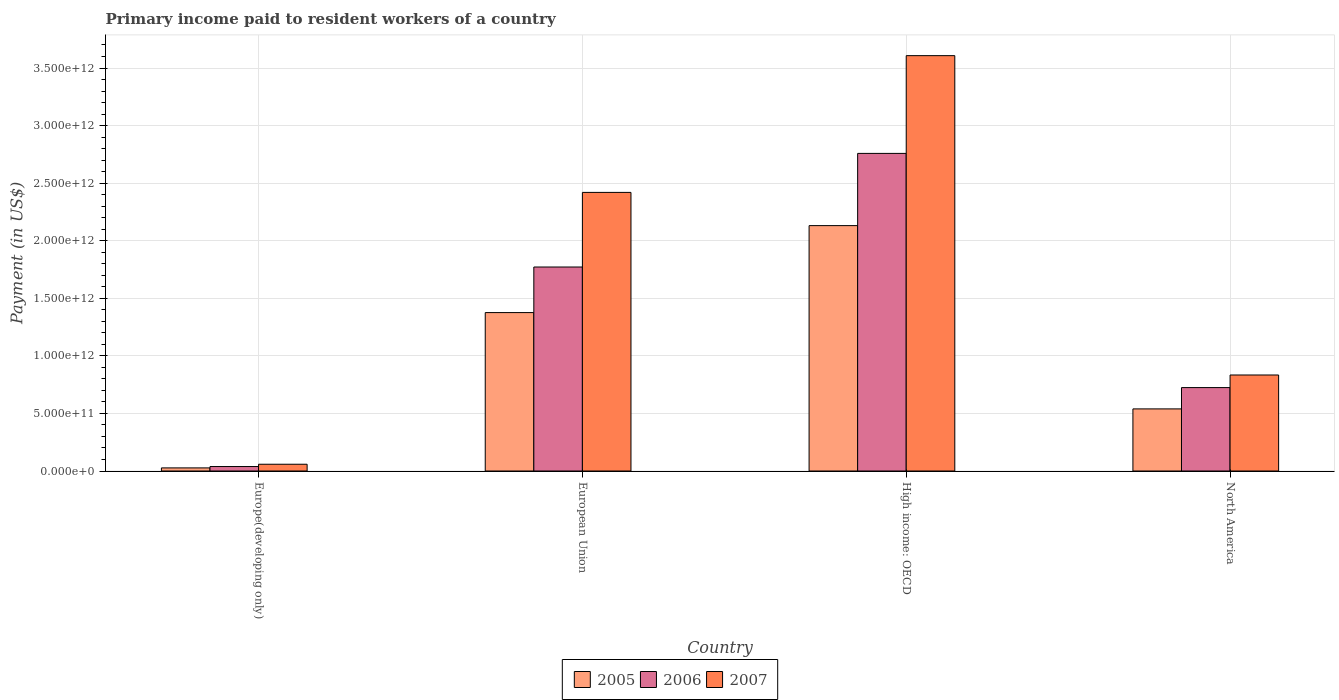How many groups of bars are there?
Provide a short and direct response. 4. Are the number of bars on each tick of the X-axis equal?
Ensure brevity in your answer.  Yes. What is the label of the 3rd group of bars from the left?
Offer a terse response. High income: OECD. What is the amount paid to workers in 2007 in North America?
Your answer should be very brief. 8.34e+11. Across all countries, what is the maximum amount paid to workers in 2007?
Give a very brief answer. 3.61e+12. Across all countries, what is the minimum amount paid to workers in 2006?
Your answer should be very brief. 3.88e+1. In which country was the amount paid to workers in 2007 maximum?
Offer a terse response. High income: OECD. In which country was the amount paid to workers in 2006 minimum?
Offer a terse response. Europe(developing only). What is the total amount paid to workers in 2005 in the graph?
Your answer should be very brief. 4.07e+12. What is the difference between the amount paid to workers in 2005 in Europe(developing only) and that in High income: OECD?
Provide a short and direct response. -2.10e+12. What is the difference between the amount paid to workers in 2005 in European Union and the amount paid to workers in 2006 in Europe(developing only)?
Your answer should be very brief. 1.34e+12. What is the average amount paid to workers in 2006 per country?
Ensure brevity in your answer.  1.32e+12. What is the difference between the amount paid to workers of/in 2007 and amount paid to workers of/in 2006 in Europe(developing only)?
Your response must be concise. 1.99e+1. In how many countries, is the amount paid to workers in 2007 greater than 2500000000000 US$?
Give a very brief answer. 1. What is the ratio of the amount paid to workers in 2006 in Europe(developing only) to that in European Union?
Ensure brevity in your answer.  0.02. Is the difference between the amount paid to workers in 2007 in High income: OECD and North America greater than the difference between the amount paid to workers in 2006 in High income: OECD and North America?
Offer a terse response. Yes. What is the difference between the highest and the second highest amount paid to workers in 2006?
Give a very brief answer. -9.87e+11. What is the difference between the highest and the lowest amount paid to workers in 2005?
Your answer should be very brief. 2.10e+12. In how many countries, is the amount paid to workers in 2007 greater than the average amount paid to workers in 2007 taken over all countries?
Offer a very short reply. 2. Is the sum of the amount paid to workers in 2005 in European Union and North America greater than the maximum amount paid to workers in 2006 across all countries?
Make the answer very short. No. What does the 3rd bar from the left in North America represents?
Ensure brevity in your answer.  2007. Is it the case that in every country, the sum of the amount paid to workers in 2005 and amount paid to workers in 2006 is greater than the amount paid to workers in 2007?
Your response must be concise. Yes. Are all the bars in the graph horizontal?
Provide a short and direct response. No. What is the difference between two consecutive major ticks on the Y-axis?
Provide a short and direct response. 5.00e+11. Are the values on the major ticks of Y-axis written in scientific E-notation?
Your response must be concise. Yes. Does the graph contain any zero values?
Provide a succinct answer. No. Does the graph contain grids?
Ensure brevity in your answer.  Yes. Where does the legend appear in the graph?
Offer a very short reply. Bottom center. How are the legend labels stacked?
Provide a succinct answer. Horizontal. What is the title of the graph?
Your answer should be very brief. Primary income paid to resident workers of a country. What is the label or title of the Y-axis?
Your answer should be compact. Payment (in US$). What is the Payment (in US$) in 2005 in Europe(developing only)?
Offer a very short reply. 2.70e+1. What is the Payment (in US$) of 2006 in Europe(developing only)?
Your answer should be compact. 3.88e+1. What is the Payment (in US$) of 2007 in Europe(developing only)?
Make the answer very short. 5.87e+1. What is the Payment (in US$) of 2005 in European Union?
Make the answer very short. 1.38e+12. What is the Payment (in US$) in 2006 in European Union?
Offer a terse response. 1.77e+12. What is the Payment (in US$) in 2007 in European Union?
Provide a succinct answer. 2.42e+12. What is the Payment (in US$) of 2005 in High income: OECD?
Keep it short and to the point. 2.13e+12. What is the Payment (in US$) in 2006 in High income: OECD?
Ensure brevity in your answer.  2.76e+12. What is the Payment (in US$) in 2007 in High income: OECD?
Your response must be concise. 3.61e+12. What is the Payment (in US$) of 2005 in North America?
Provide a succinct answer. 5.39e+11. What is the Payment (in US$) in 2006 in North America?
Ensure brevity in your answer.  7.24e+11. What is the Payment (in US$) of 2007 in North America?
Provide a succinct answer. 8.34e+11. Across all countries, what is the maximum Payment (in US$) in 2005?
Keep it short and to the point. 2.13e+12. Across all countries, what is the maximum Payment (in US$) in 2006?
Offer a terse response. 2.76e+12. Across all countries, what is the maximum Payment (in US$) of 2007?
Offer a terse response. 3.61e+12. Across all countries, what is the minimum Payment (in US$) of 2005?
Make the answer very short. 2.70e+1. Across all countries, what is the minimum Payment (in US$) of 2006?
Offer a very short reply. 3.88e+1. Across all countries, what is the minimum Payment (in US$) of 2007?
Offer a terse response. 5.87e+1. What is the total Payment (in US$) of 2005 in the graph?
Offer a terse response. 4.07e+12. What is the total Payment (in US$) in 2006 in the graph?
Your answer should be compact. 5.29e+12. What is the total Payment (in US$) of 2007 in the graph?
Offer a very short reply. 6.92e+12. What is the difference between the Payment (in US$) of 2005 in Europe(developing only) and that in European Union?
Your answer should be compact. -1.35e+12. What is the difference between the Payment (in US$) of 2006 in Europe(developing only) and that in European Union?
Your answer should be compact. -1.73e+12. What is the difference between the Payment (in US$) in 2007 in Europe(developing only) and that in European Union?
Keep it short and to the point. -2.36e+12. What is the difference between the Payment (in US$) of 2005 in Europe(developing only) and that in High income: OECD?
Provide a succinct answer. -2.10e+12. What is the difference between the Payment (in US$) of 2006 in Europe(developing only) and that in High income: OECD?
Keep it short and to the point. -2.72e+12. What is the difference between the Payment (in US$) in 2007 in Europe(developing only) and that in High income: OECD?
Make the answer very short. -3.55e+12. What is the difference between the Payment (in US$) in 2005 in Europe(developing only) and that in North America?
Make the answer very short. -5.12e+11. What is the difference between the Payment (in US$) in 2006 in Europe(developing only) and that in North America?
Keep it short and to the point. -6.86e+11. What is the difference between the Payment (in US$) in 2007 in Europe(developing only) and that in North America?
Keep it short and to the point. -7.75e+11. What is the difference between the Payment (in US$) in 2005 in European Union and that in High income: OECD?
Offer a very short reply. -7.55e+11. What is the difference between the Payment (in US$) of 2006 in European Union and that in High income: OECD?
Give a very brief answer. -9.87e+11. What is the difference between the Payment (in US$) in 2007 in European Union and that in High income: OECD?
Offer a terse response. -1.19e+12. What is the difference between the Payment (in US$) of 2005 in European Union and that in North America?
Your response must be concise. 8.36e+11. What is the difference between the Payment (in US$) of 2006 in European Union and that in North America?
Provide a short and direct response. 1.05e+12. What is the difference between the Payment (in US$) of 2007 in European Union and that in North America?
Offer a terse response. 1.59e+12. What is the difference between the Payment (in US$) of 2005 in High income: OECD and that in North America?
Your answer should be compact. 1.59e+12. What is the difference between the Payment (in US$) of 2006 in High income: OECD and that in North America?
Make the answer very short. 2.03e+12. What is the difference between the Payment (in US$) of 2007 in High income: OECD and that in North America?
Ensure brevity in your answer.  2.77e+12. What is the difference between the Payment (in US$) of 2005 in Europe(developing only) and the Payment (in US$) of 2006 in European Union?
Your response must be concise. -1.74e+12. What is the difference between the Payment (in US$) of 2005 in Europe(developing only) and the Payment (in US$) of 2007 in European Union?
Make the answer very short. -2.39e+12. What is the difference between the Payment (in US$) in 2006 in Europe(developing only) and the Payment (in US$) in 2007 in European Union?
Make the answer very short. -2.38e+12. What is the difference between the Payment (in US$) in 2005 in Europe(developing only) and the Payment (in US$) in 2006 in High income: OECD?
Keep it short and to the point. -2.73e+12. What is the difference between the Payment (in US$) of 2005 in Europe(developing only) and the Payment (in US$) of 2007 in High income: OECD?
Offer a terse response. -3.58e+12. What is the difference between the Payment (in US$) in 2006 in Europe(developing only) and the Payment (in US$) in 2007 in High income: OECD?
Your response must be concise. -3.57e+12. What is the difference between the Payment (in US$) in 2005 in Europe(developing only) and the Payment (in US$) in 2006 in North America?
Give a very brief answer. -6.98e+11. What is the difference between the Payment (in US$) of 2005 in Europe(developing only) and the Payment (in US$) of 2007 in North America?
Offer a terse response. -8.07e+11. What is the difference between the Payment (in US$) in 2006 in Europe(developing only) and the Payment (in US$) in 2007 in North America?
Offer a very short reply. -7.95e+11. What is the difference between the Payment (in US$) in 2005 in European Union and the Payment (in US$) in 2006 in High income: OECD?
Offer a very short reply. -1.38e+12. What is the difference between the Payment (in US$) of 2005 in European Union and the Payment (in US$) of 2007 in High income: OECD?
Offer a very short reply. -2.23e+12. What is the difference between the Payment (in US$) of 2006 in European Union and the Payment (in US$) of 2007 in High income: OECD?
Ensure brevity in your answer.  -1.84e+12. What is the difference between the Payment (in US$) in 2005 in European Union and the Payment (in US$) in 2006 in North America?
Offer a terse response. 6.51e+11. What is the difference between the Payment (in US$) in 2005 in European Union and the Payment (in US$) in 2007 in North America?
Provide a short and direct response. 5.42e+11. What is the difference between the Payment (in US$) of 2006 in European Union and the Payment (in US$) of 2007 in North America?
Offer a terse response. 9.38e+11. What is the difference between the Payment (in US$) of 2005 in High income: OECD and the Payment (in US$) of 2006 in North America?
Ensure brevity in your answer.  1.41e+12. What is the difference between the Payment (in US$) of 2005 in High income: OECD and the Payment (in US$) of 2007 in North America?
Your answer should be compact. 1.30e+12. What is the difference between the Payment (in US$) in 2006 in High income: OECD and the Payment (in US$) in 2007 in North America?
Keep it short and to the point. 1.92e+12. What is the average Payment (in US$) in 2005 per country?
Give a very brief answer. 1.02e+12. What is the average Payment (in US$) in 2006 per country?
Your answer should be compact. 1.32e+12. What is the average Payment (in US$) in 2007 per country?
Provide a succinct answer. 1.73e+12. What is the difference between the Payment (in US$) of 2005 and Payment (in US$) of 2006 in Europe(developing only)?
Offer a very short reply. -1.18e+1. What is the difference between the Payment (in US$) of 2005 and Payment (in US$) of 2007 in Europe(developing only)?
Ensure brevity in your answer.  -3.17e+1. What is the difference between the Payment (in US$) of 2006 and Payment (in US$) of 2007 in Europe(developing only)?
Make the answer very short. -1.99e+1. What is the difference between the Payment (in US$) in 2005 and Payment (in US$) in 2006 in European Union?
Give a very brief answer. -3.96e+11. What is the difference between the Payment (in US$) of 2005 and Payment (in US$) of 2007 in European Union?
Your answer should be compact. -1.04e+12. What is the difference between the Payment (in US$) of 2006 and Payment (in US$) of 2007 in European Union?
Give a very brief answer. -6.48e+11. What is the difference between the Payment (in US$) in 2005 and Payment (in US$) in 2006 in High income: OECD?
Keep it short and to the point. -6.27e+11. What is the difference between the Payment (in US$) in 2005 and Payment (in US$) in 2007 in High income: OECD?
Your response must be concise. -1.48e+12. What is the difference between the Payment (in US$) in 2006 and Payment (in US$) in 2007 in High income: OECD?
Provide a succinct answer. -8.49e+11. What is the difference between the Payment (in US$) of 2005 and Payment (in US$) of 2006 in North America?
Your answer should be compact. -1.85e+11. What is the difference between the Payment (in US$) in 2005 and Payment (in US$) in 2007 in North America?
Provide a short and direct response. -2.94e+11. What is the difference between the Payment (in US$) of 2006 and Payment (in US$) of 2007 in North America?
Give a very brief answer. -1.09e+11. What is the ratio of the Payment (in US$) in 2005 in Europe(developing only) to that in European Union?
Ensure brevity in your answer.  0.02. What is the ratio of the Payment (in US$) in 2006 in Europe(developing only) to that in European Union?
Your answer should be compact. 0.02. What is the ratio of the Payment (in US$) of 2007 in Europe(developing only) to that in European Union?
Offer a terse response. 0.02. What is the ratio of the Payment (in US$) of 2005 in Europe(developing only) to that in High income: OECD?
Offer a very short reply. 0.01. What is the ratio of the Payment (in US$) of 2006 in Europe(developing only) to that in High income: OECD?
Provide a succinct answer. 0.01. What is the ratio of the Payment (in US$) of 2007 in Europe(developing only) to that in High income: OECD?
Ensure brevity in your answer.  0.02. What is the ratio of the Payment (in US$) in 2005 in Europe(developing only) to that in North America?
Provide a succinct answer. 0.05. What is the ratio of the Payment (in US$) of 2006 in Europe(developing only) to that in North America?
Offer a very short reply. 0.05. What is the ratio of the Payment (in US$) of 2007 in Europe(developing only) to that in North America?
Your response must be concise. 0.07. What is the ratio of the Payment (in US$) in 2005 in European Union to that in High income: OECD?
Your answer should be very brief. 0.65. What is the ratio of the Payment (in US$) in 2006 in European Union to that in High income: OECD?
Your answer should be very brief. 0.64. What is the ratio of the Payment (in US$) of 2007 in European Union to that in High income: OECD?
Keep it short and to the point. 0.67. What is the ratio of the Payment (in US$) of 2005 in European Union to that in North America?
Your answer should be very brief. 2.55. What is the ratio of the Payment (in US$) of 2006 in European Union to that in North America?
Your response must be concise. 2.45. What is the ratio of the Payment (in US$) of 2007 in European Union to that in North America?
Provide a short and direct response. 2.9. What is the ratio of the Payment (in US$) in 2005 in High income: OECD to that in North America?
Offer a terse response. 3.95. What is the ratio of the Payment (in US$) of 2006 in High income: OECD to that in North America?
Make the answer very short. 3.81. What is the ratio of the Payment (in US$) in 2007 in High income: OECD to that in North America?
Ensure brevity in your answer.  4.33. What is the difference between the highest and the second highest Payment (in US$) in 2005?
Your response must be concise. 7.55e+11. What is the difference between the highest and the second highest Payment (in US$) of 2006?
Give a very brief answer. 9.87e+11. What is the difference between the highest and the second highest Payment (in US$) in 2007?
Your answer should be very brief. 1.19e+12. What is the difference between the highest and the lowest Payment (in US$) in 2005?
Offer a very short reply. 2.10e+12. What is the difference between the highest and the lowest Payment (in US$) of 2006?
Offer a terse response. 2.72e+12. What is the difference between the highest and the lowest Payment (in US$) in 2007?
Give a very brief answer. 3.55e+12. 